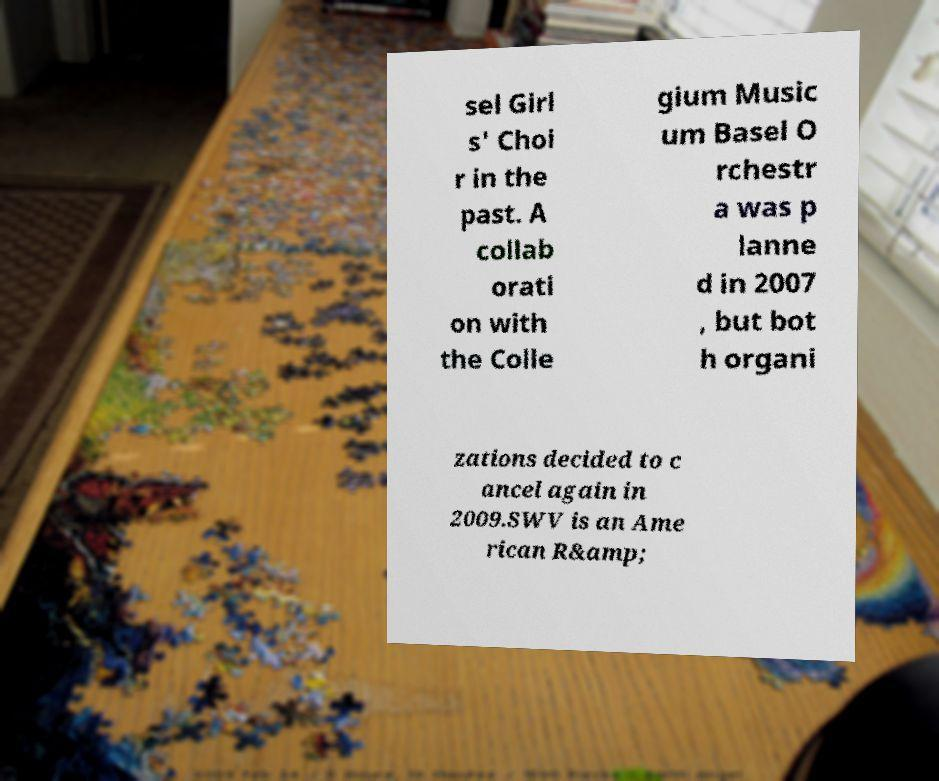There's text embedded in this image that I need extracted. Can you transcribe it verbatim? sel Girl s' Choi r in the past. A collab orati on with the Colle gium Music um Basel O rchestr a was p lanne d in 2007 , but bot h organi zations decided to c ancel again in 2009.SWV is an Ame rican R&amp; 